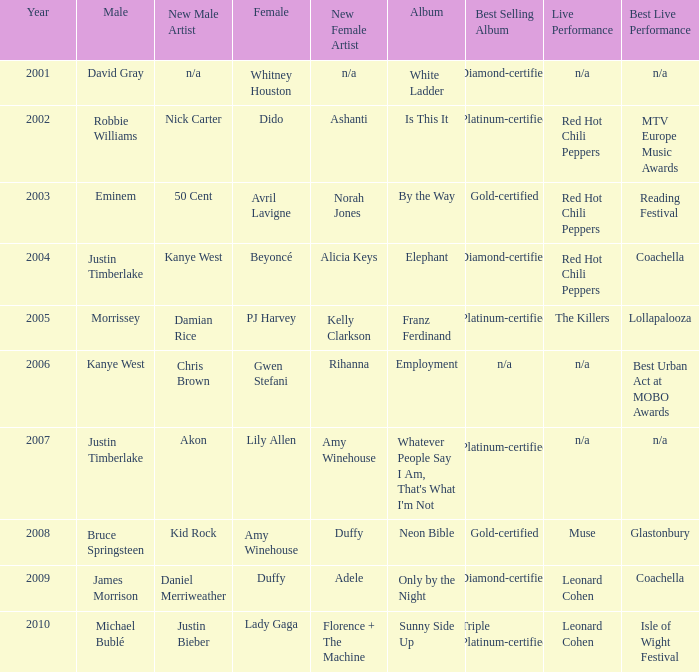Who is the male partner for amy winehouse? Bruce Springsteen. 